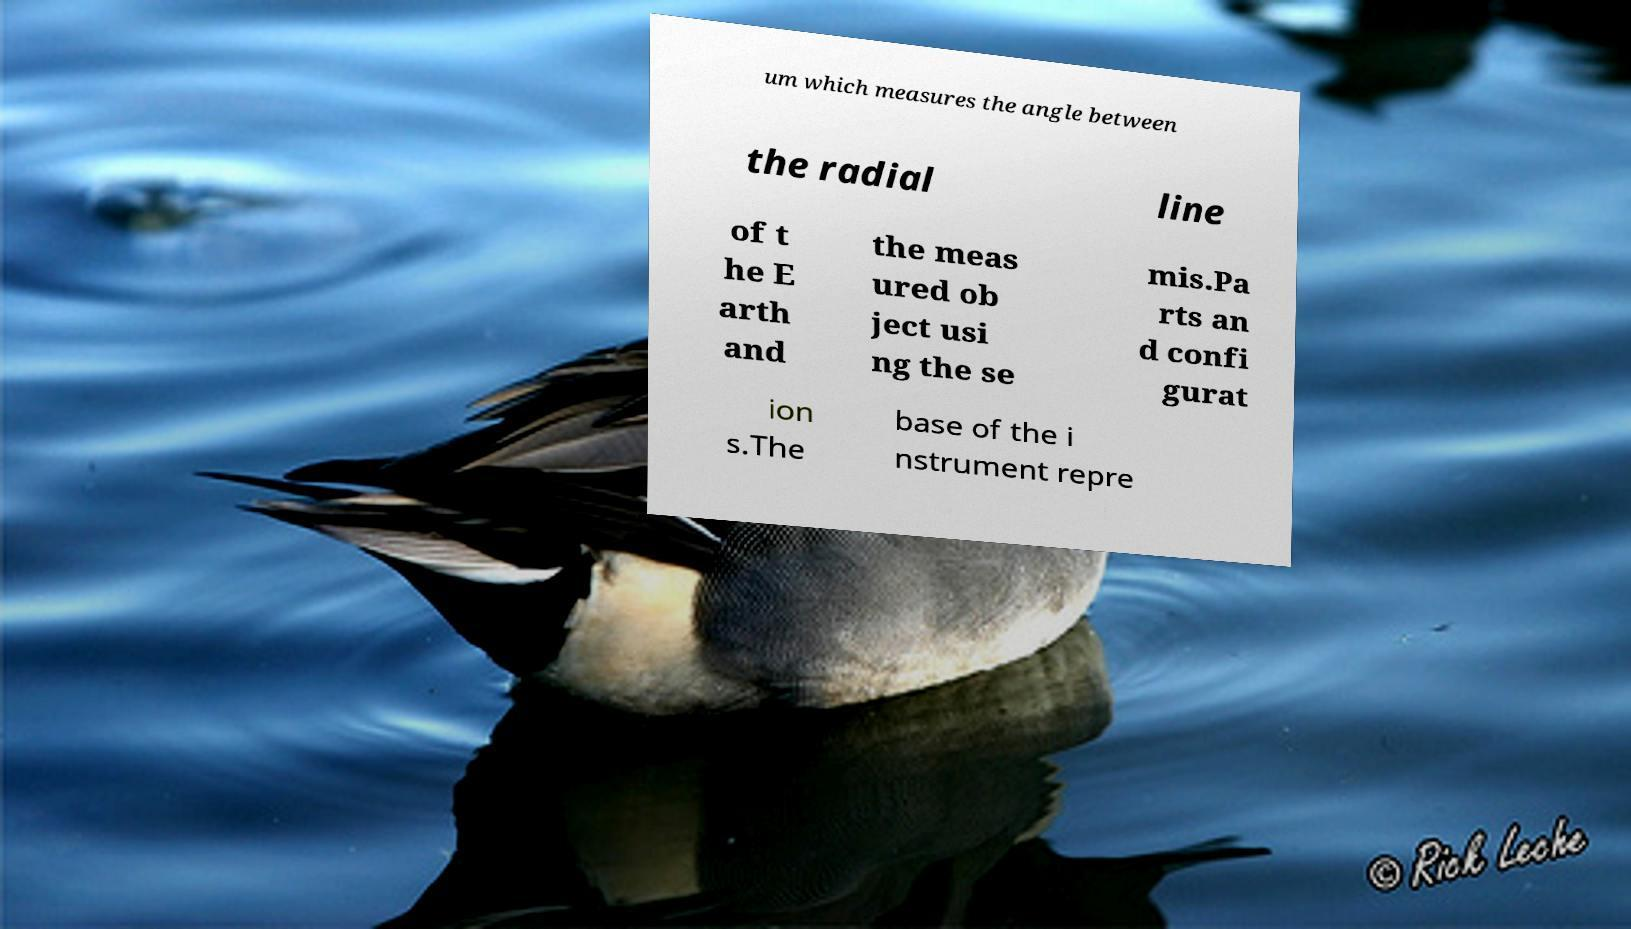Can you accurately transcribe the text from the provided image for me? um which measures the angle between the radial line of t he E arth and the meas ured ob ject usi ng the se mis.Pa rts an d confi gurat ion s.The base of the i nstrument repre 